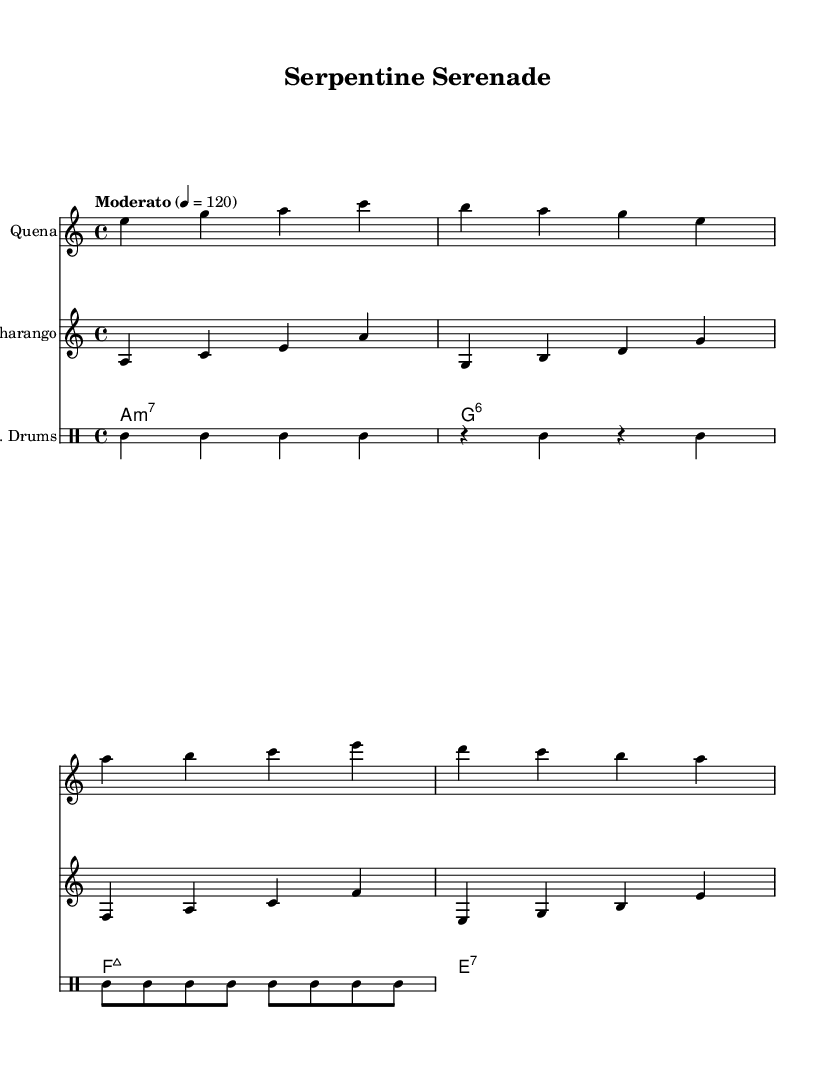What is the key signature of this music? The key signature is A minor, which has no sharps or flats, as indicated at the beginning of the score.
Answer: A minor What is the time signature of this music? The time signature is 4/4, as noted at the beginning of the score, which indicates four beats per measure with a quarter note receiving one beat.
Answer: 4/4 What is the tempo marking for this piece? The tempo marking is "Moderato" with a metronome indication of 120 beats per minute, suggesting a moderate speed for the performance of the music.
Answer: Moderato 120 How many measures are in the Quena part? The Quena part contains four measures, each separated by vertical bar lines, which visually divide the music into measures as standard in sheet music notation.
Answer: 4 What is the instrument name for the second staff? The instrument name for the second staff is "Charango," as specified in the score header for that particular staff, indicating the instrument's identity.
Answer: Charango What type of drum style is indicated in this score? The score indicates "E. Drums" which implies an electronic drum style, likely incorporating electronic effects alongside traditional drum patterns indicated in the drummode section.
Answer: E. Drums What chord sequence is used in the synth part? The chord sequence in the synth part is A minor seven, G sixth, F major seven, and E seven, as shown in the chord mode section of the music.
Answer: A minor seven, G sixth, F major seven, E seven 